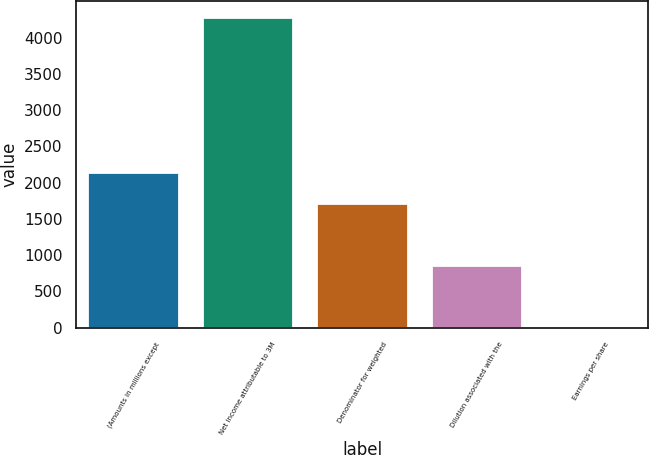Convert chart. <chart><loc_0><loc_0><loc_500><loc_500><bar_chart><fcel>(Amounts in millions except<fcel>Net income attributable to 3M<fcel>Denominator for weighted<fcel>Dilution associated with the<fcel>Earnings per share<nl><fcel>2144.46<fcel>4283<fcel>1716.76<fcel>861.36<fcel>5.96<nl></chart> 